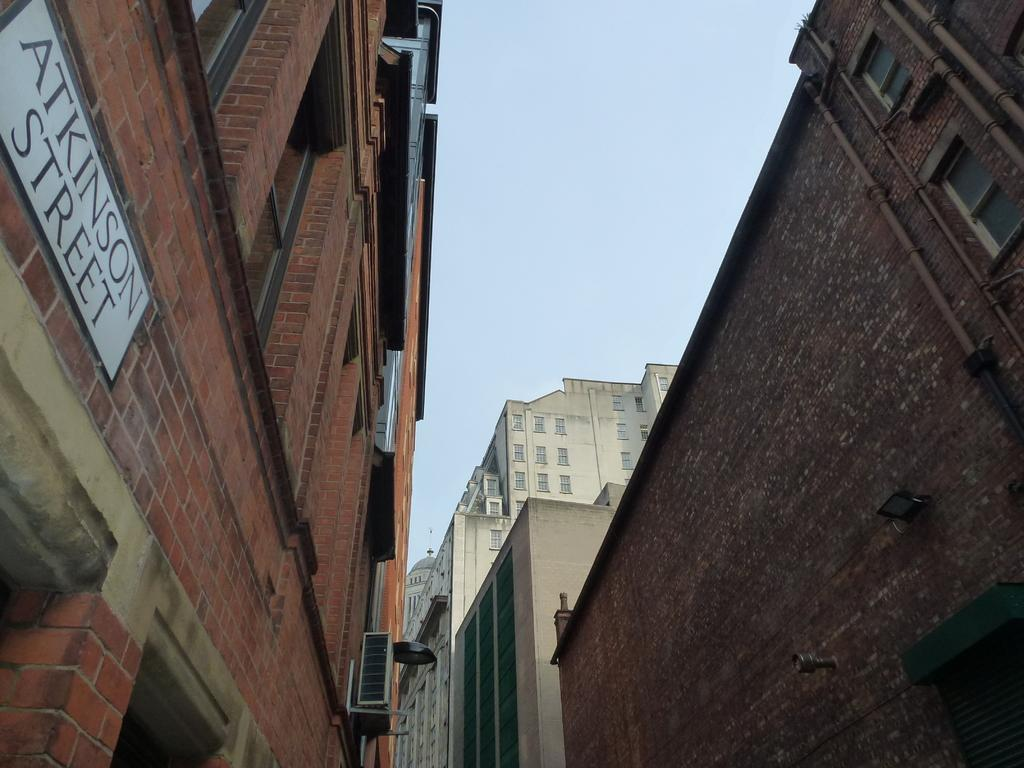What type of structures are visible in the image? There are buildings with windows in the image. What can be seen on the buildings in the image? There is a name board on one of the buildings. Can you describe the object in the image? Unfortunately, the facts provided do not give enough information to describe the object in the image. What is visible in the background of the image? The sky is visible behind the buildings in the image. What type of veil is draped over the buildings in the image? There is no veil present in the image; the buildings have windows and a name board. How many mint leaves are scattered on the ground in the image? There is no mention of mint leaves in the image; the facts provided only mention buildings, a name board, an object, and the sky. 